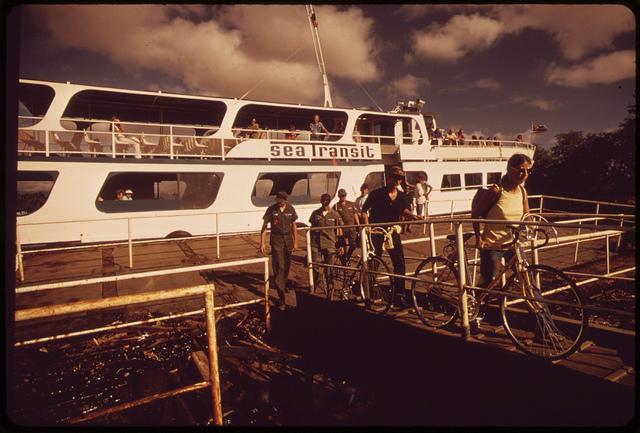How many vehicles are pictured?
Be succinct. 3. How fast will the take you from one stop to the other?
Quick response, please. Slow. What words are on the side of the boat?
Write a very short answer. Sea transit. Are there any people on the bridge?
Be succinct. Yes. What kind of boat is this?
Quick response, please. Ferry. 